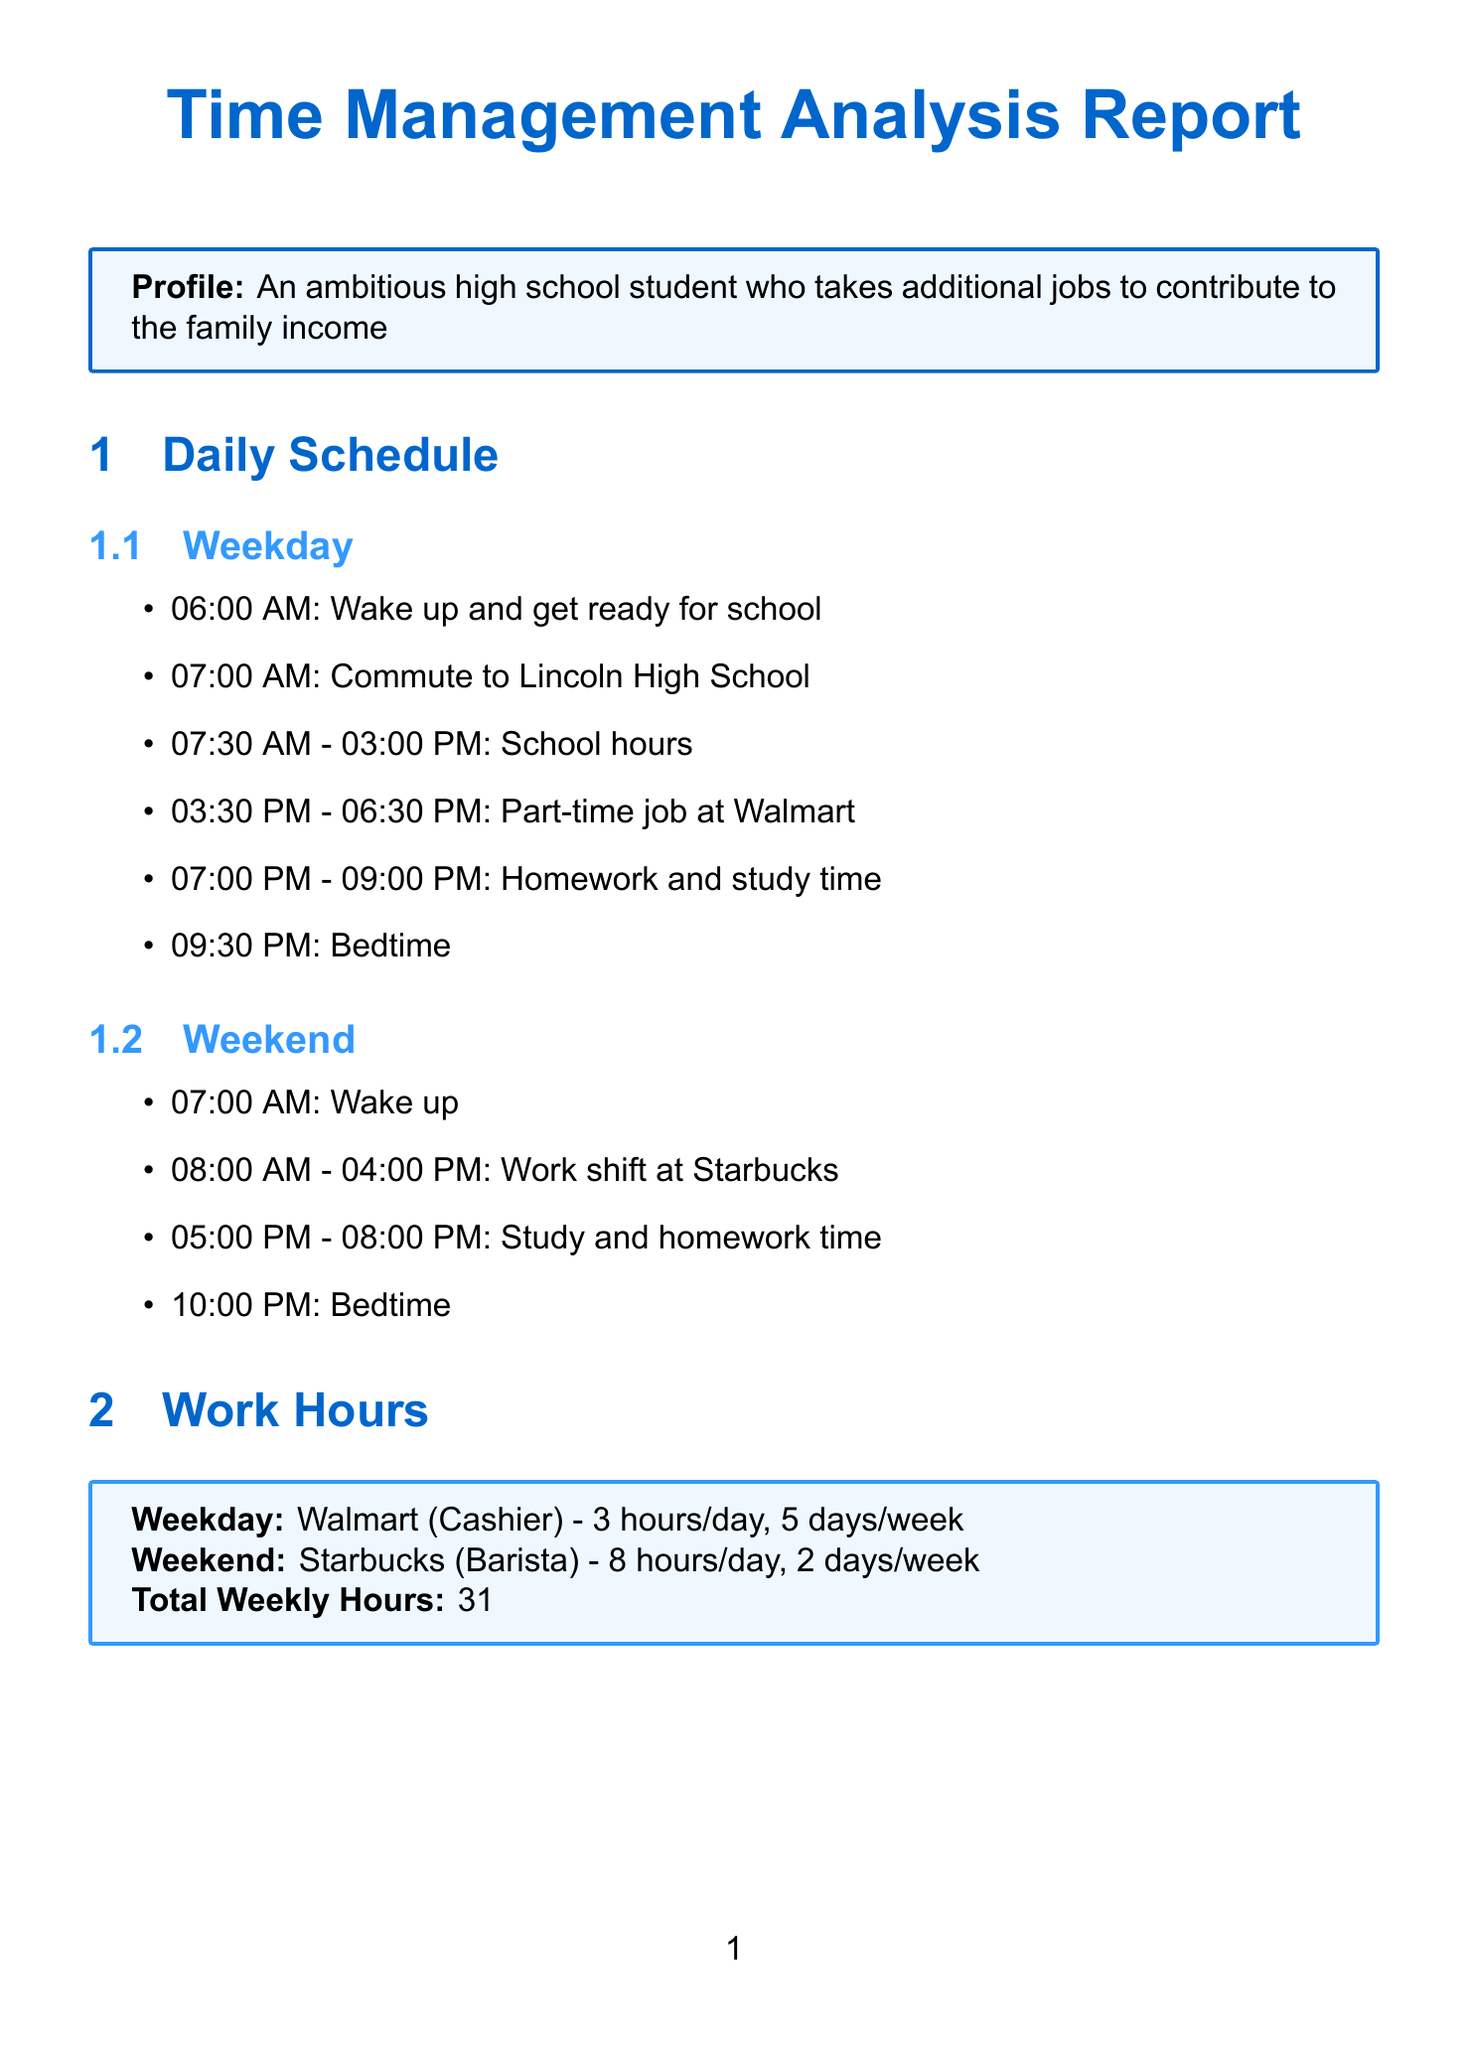What are the school hours on weekdays? The school hours on weekdays are from 7:30 AM to 3:00 PM.
Answer: 7:30 AM - 03:00 PM How many hours does the student work at Walmart during the week? The student works 3 hours per day at Walmart for 5 days each week.
Answer: 15 hours What is the total weekly study time? The total weekly study time is the sum of weekday and weekend study hours, which is 2 hours per day for 5 days plus 3 hours per day for 2 days.
Answer: 16 hours What are the subjects being studied on weekdays? The subjects studied on weekdays include Mathematics, Physics, English Literature, and History.
Answer: Mathematics, Physics, English Literature, History How many hours of sleep does the student currently average on weekdays? The student currently averages 7 hours of sleep on weekdays.
Answer: 7 hours What is the savings goal for the college fund? The savings goal for the college fund is stated in the financial section of the document.
Answer: $200 per month What career goal does the student aspire to achieve? The career goal indicated within the future aspirations of the document is to become a software engineer.
Answer: Software Engineer What extracurricular activity time is recommended for improvement? The recommendation is to dedicate a certain amount of time each week for extracurricular activities.
Answer: 2 hours per week What is the current GPA of the student? The current GPA is found within the academic performance section of the report.
Answer: 3.7 